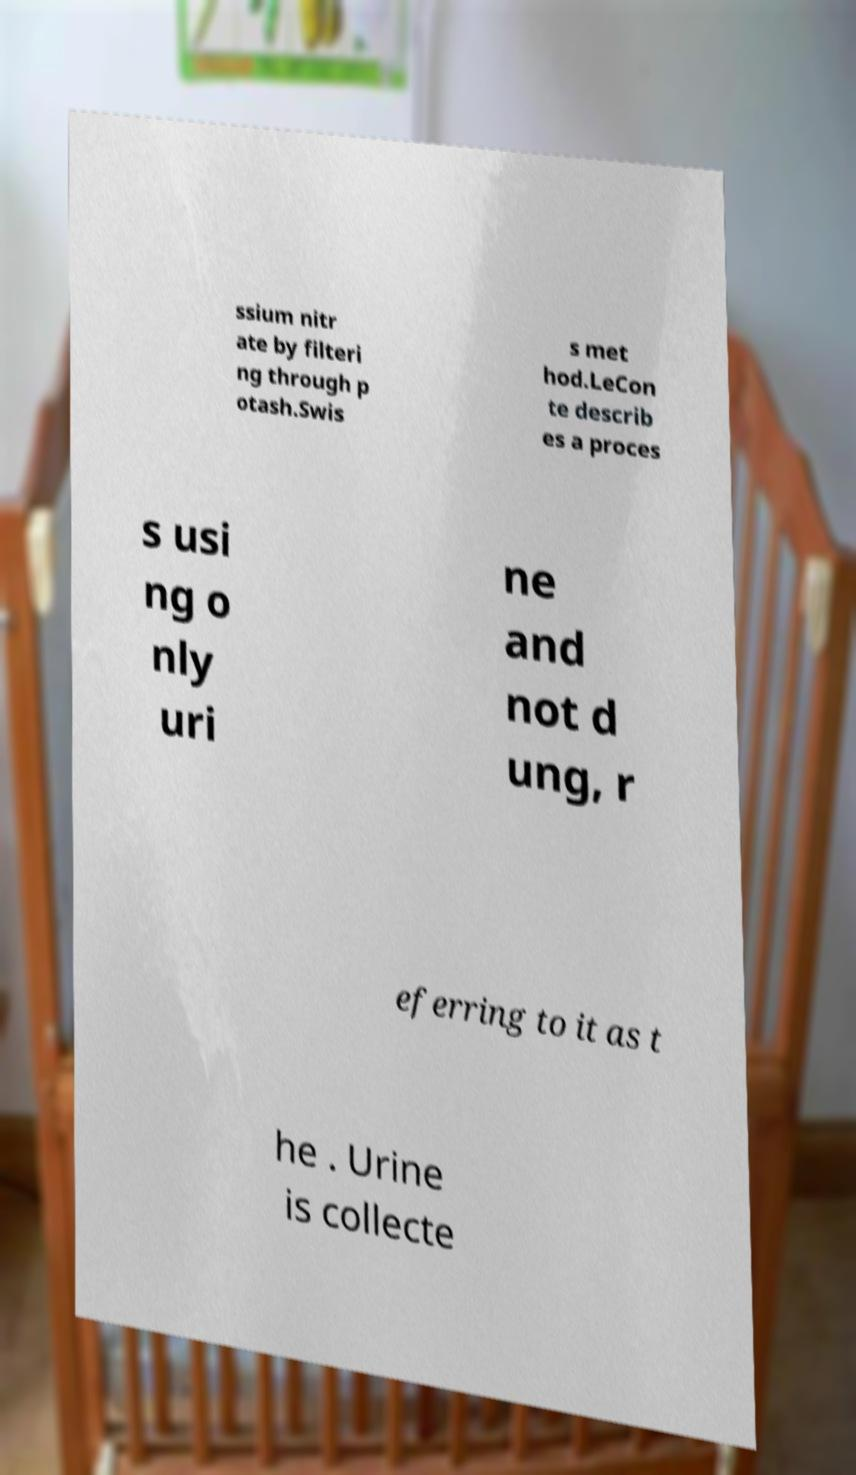For documentation purposes, I need the text within this image transcribed. Could you provide that? ssium nitr ate by filteri ng through p otash.Swis s met hod.LeCon te describ es a proces s usi ng o nly uri ne and not d ung, r eferring to it as t he . Urine is collecte 